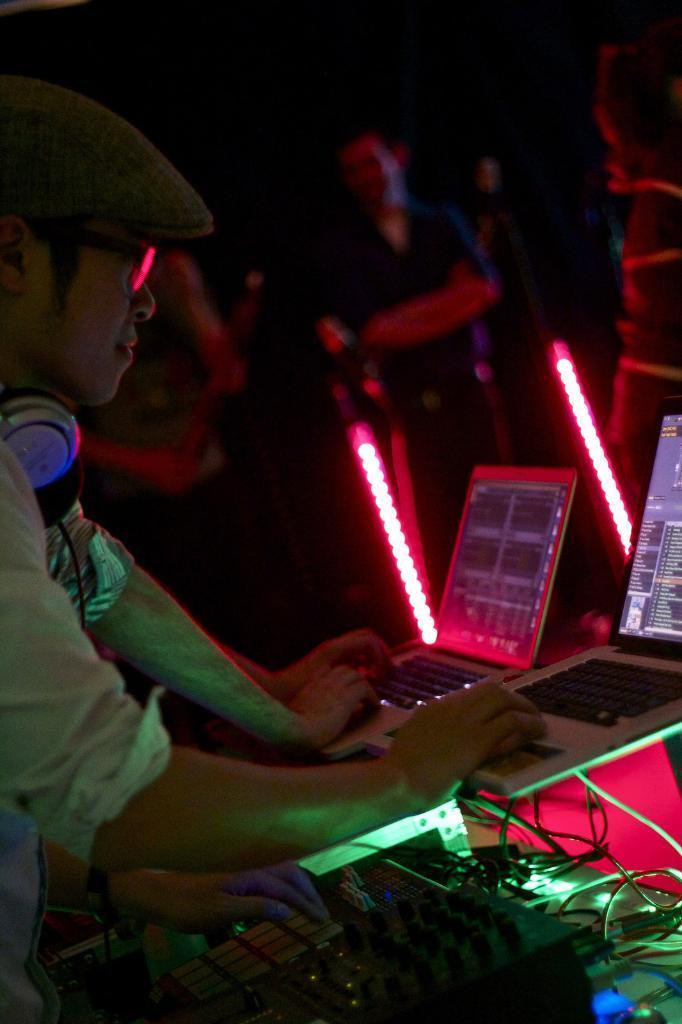Could you give a brief overview of what you see in this image? On the left side of the image we can see some people are standing and operating laptops and a man is playing DJ and a man is wearing a headset. In the background of the image we can see the lights and some people are standing. At the bottom of the image we can see the amplifier, wires and lights. At the top, the image is dark. 